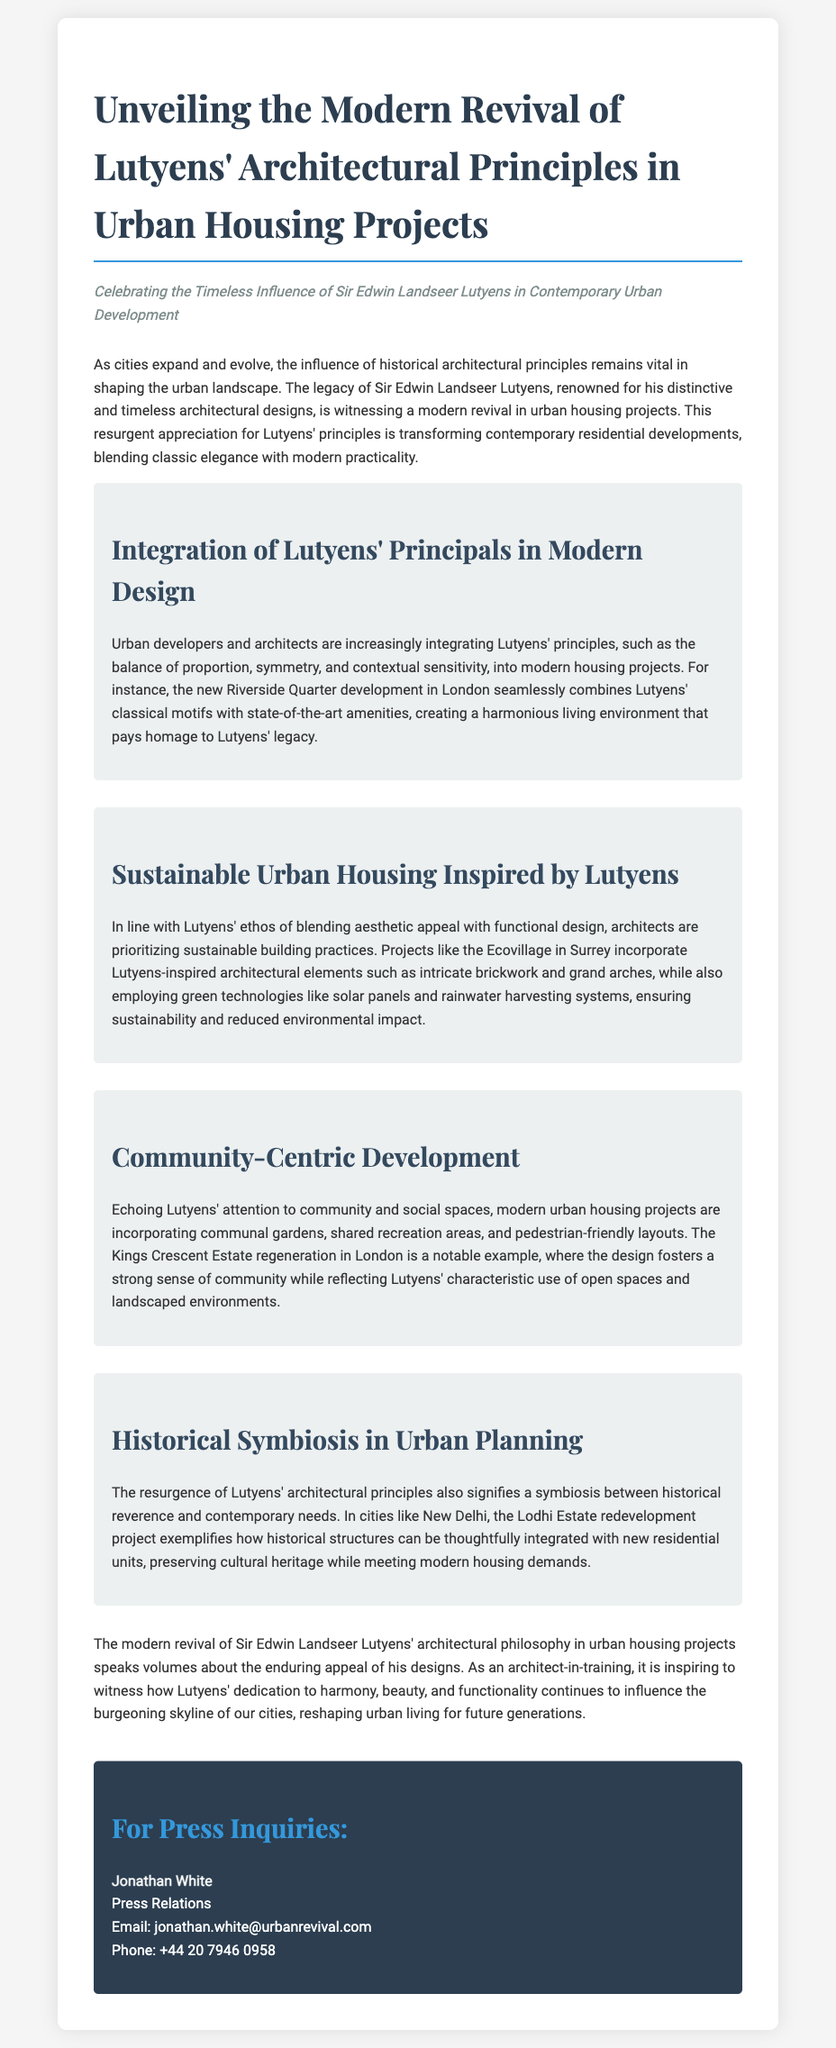What is the title of the press release? The title is explicitly stated at the top of the document.
Answer: Unveiling the Modern Revival of Lutyens' Architectural Principles in Urban Housing Projects Who is the press contact for inquiries? This information includes the name and title of the press contact person, typically found at the end of press releases.
Answer: Jonathan White What is one example of a project that integrates Lutyens' principles? The document mentions specific projects that incorporate Lutyens' architectural principles.
Answer: Riverside Quarter What sustainable technology is mentioned in relation to the Ecovillage project? The document specifically lists technologies utilized in sustainable projects.
Answer: Solar panels What type of community features are mentioned in modern urban housing projects? The document describes various features aimed at enhancing community interaction.
Answer: Communal gardens What does the press release suggest about the relationship between historical and contemporary architectural needs? The text discusses the balance between maintaining historical charm and meeting modern demands.
Answer: Historical reverence and contemporary needs In which city is the Kings Crescent Estate regeneration located? The press release refers to the location of particular projects, including this one.
Answer: London 